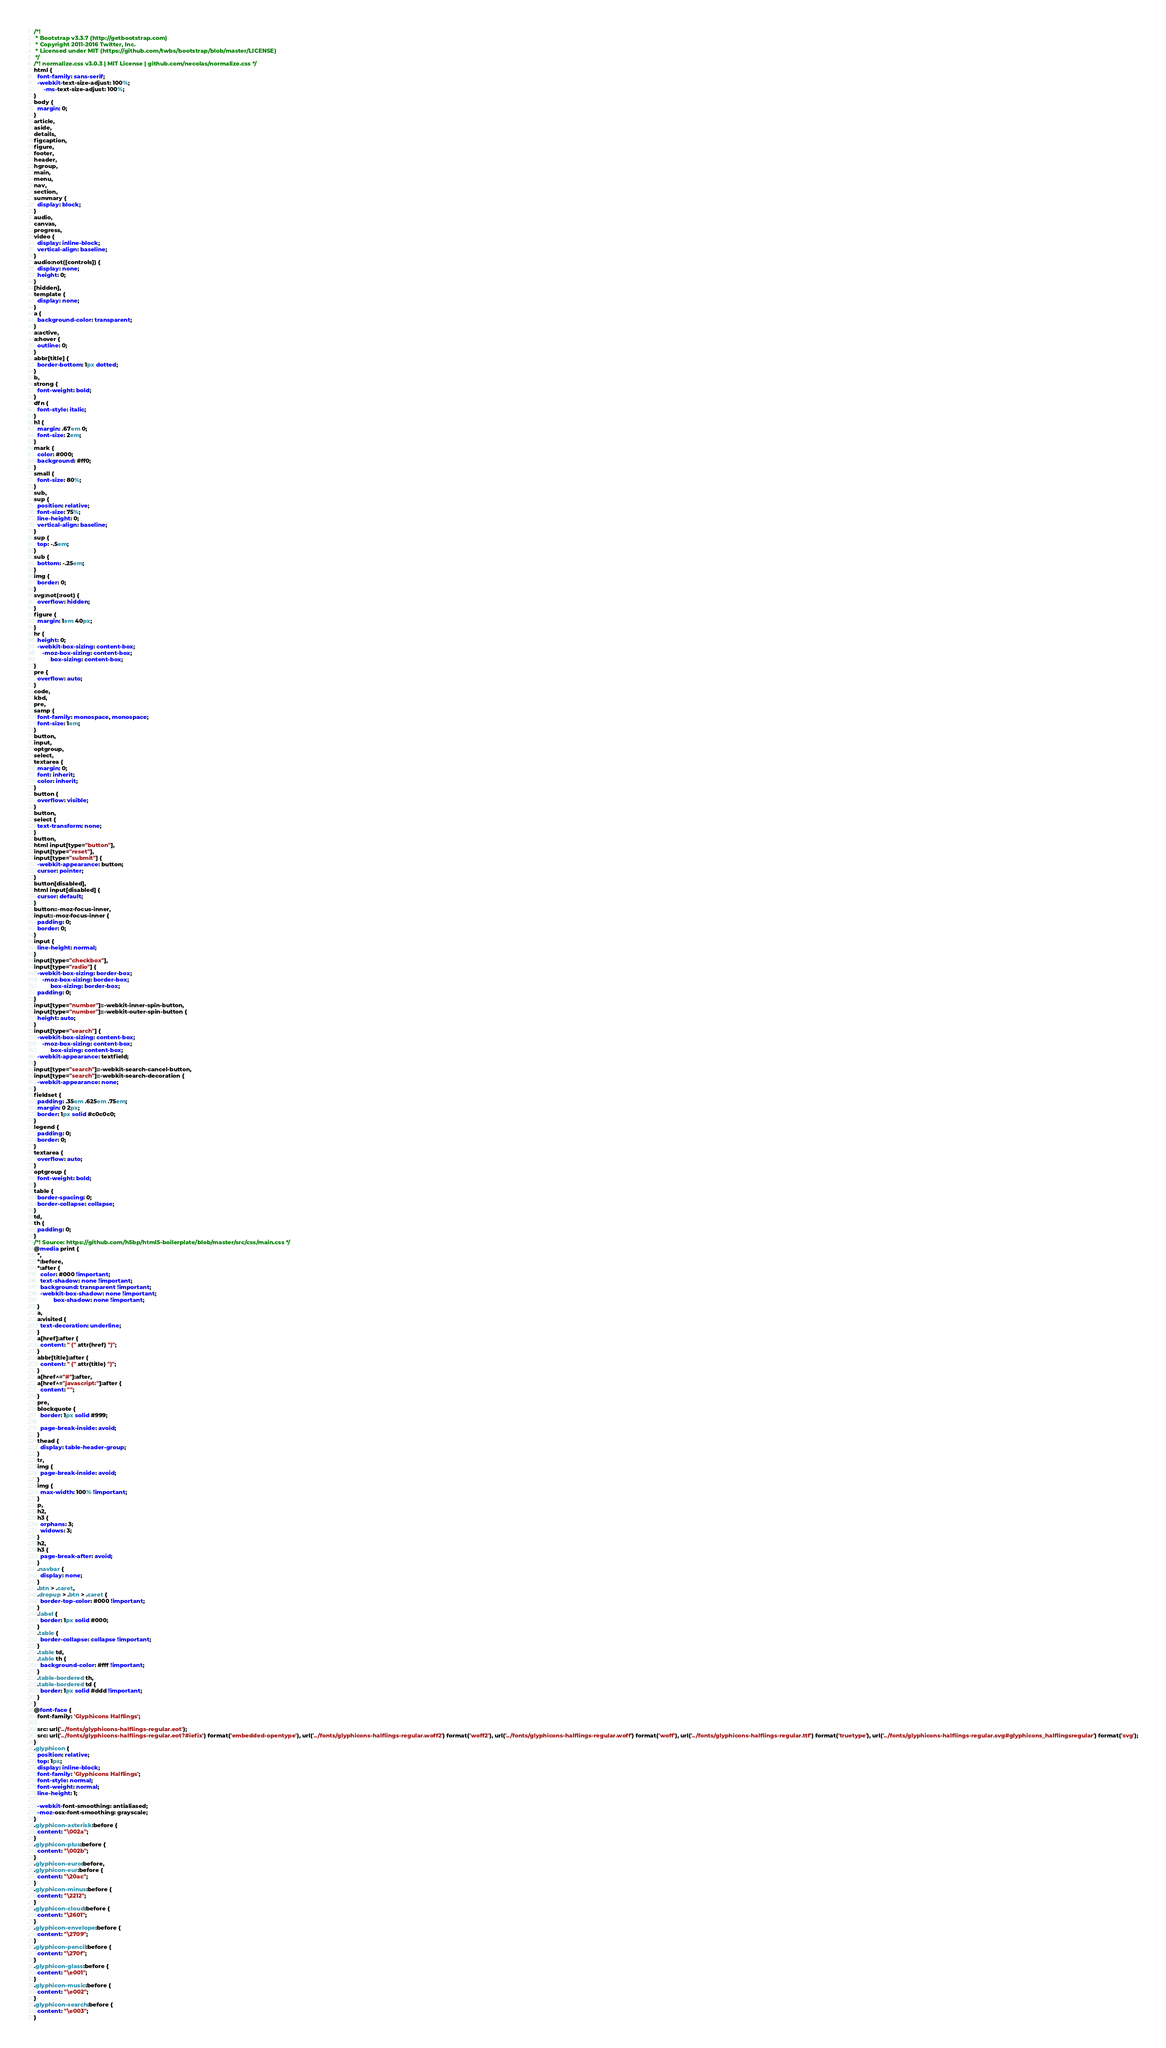Convert code to text. <code><loc_0><loc_0><loc_500><loc_500><_CSS_>/*!
 * Bootstrap v3.3.7 (http://getbootstrap.com)
 * Copyright 2011-2016 Twitter, Inc.
 * Licensed under MIT (https://github.com/twbs/bootstrap/blob/master/LICENSE)
 */
/*! normalize.css v3.0.3 | MIT License | github.com/necolas/normalize.css */
html {
  font-family: sans-serif;
  -webkit-text-size-adjust: 100%;
      -ms-text-size-adjust: 100%;
}
body {
  margin: 0;
}
article,
aside,
details,
figcaption,
figure,
footer,
header,
hgroup,
main,
menu,
nav,
section,
summary {
  display: block;
}
audio,
canvas,
progress,
video {
  display: inline-block;
  vertical-align: baseline;
}
audio:not([controls]) {
  display: none;
  height: 0;
}
[hidden],
template {
  display: none;
}
a {
  background-color: transparent;
}
a:active,
a:hover {
  outline: 0;
}
abbr[title] {
  border-bottom: 1px dotted;
}
b,
strong {
  font-weight: bold;
}
dfn {
  font-style: italic;
}
h1 {
  margin: .67em 0;
  font-size: 2em;
}
mark {
  color: #000;
  background: #ff0;
}
small {
  font-size: 80%;
}
sub,
sup {
  position: relative;
  font-size: 75%;
  line-height: 0;
  vertical-align: baseline;
}
sup {
  top: -.5em;
}
sub {
  bottom: -.25em;
}
img {
  border: 0;
}
svg:not(:root) {
  overflow: hidden;
}
figure {
  margin: 1em 40px;
}
hr {
  height: 0;
  -webkit-box-sizing: content-box;
     -moz-box-sizing: content-box;
          box-sizing: content-box;
}
pre {
  overflow: auto;
}
code,
kbd,
pre,
samp {
  font-family: monospace, monospace;
  font-size: 1em;
}
button,
input,
optgroup,
select,
textarea {
  margin: 0;
  font: inherit;
  color: inherit;
}
button {
  overflow: visible;
}
button,
select {
  text-transform: none;
}
button,
html input[type="button"],
input[type="reset"],
input[type="submit"] {
  -webkit-appearance: button;
  cursor: pointer;
}
button[disabled],
html input[disabled] {
  cursor: default;
}
button::-moz-focus-inner,
input::-moz-focus-inner {
  padding: 0;
  border: 0;
}
input {
  line-height: normal;
}
input[type="checkbox"],
input[type="radio"] {
  -webkit-box-sizing: border-box;
     -moz-box-sizing: border-box;
          box-sizing: border-box;
  padding: 0;
}
input[type="number"]::-webkit-inner-spin-button,
input[type="number"]::-webkit-outer-spin-button {
  height: auto;
}
input[type="search"] {
  -webkit-box-sizing: content-box;
     -moz-box-sizing: content-box;
          box-sizing: content-box;
  -webkit-appearance: textfield;
}
input[type="search"]::-webkit-search-cancel-button,
input[type="search"]::-webkit-search-decoration {
  -webkit-appearance: none;
}
fieldset {
  padding: .35em .625em .75em;
  margin: 0 2px;
  border: 1px solid #c0c0c0;
}
legend {
  padding: 0;
  border: 0;
}
textarea {
  overflow: auto;
}
optgroup {
  font-weight: bold;
}
table {
  border-spacing: 0;
  border-collapse: collapse;
}
td,
th {
  padding: 0;
}
/*! Source: https://github.com/h5bp/html5-boilerplate/blob/master/src/css/main.css */
@media print {
  *,
  *:before,
  *:after {
    color: #000 !important;
    text-shadow: none !important;
    background: transparent !important;
    -webkit-box-shadow: none !important;
            box-shadow: none !important;
  }
  a,
  a:visited {
    text-decoration: underline;
  }
  a[href]:after {
    content: " (" attr(href) ")";
  }
  abbr[title]:after {
    content: " (" attr(title) ")";
  }
  a[href^="#"]:after,
  a[href^="javascript:"]:after {
    content: "";
  }
  pre,
  blockquote {
    border: 1px solid #999;

    page-break-inside: avoid;
  }
  thead {
    display: table-header-group;
  }
  tr,
  img {
    page-break-inside: avoid;
  }
  img {
    max-width: 100% !important;
  }
  p,
  h2,
  h3 {
    orphans: 3;
    widows: 3;
  }
  h2,
  h3 {
    page-break-after: avoid;
  }
  .navbar {
    display: none;
  }
  .btn > .caret,
  .dropup > .btn > .caret {
    border-top-color: #000 !important;
  }
  .label {
    border: 1px solid #000;
  }
  .table {
    border-collapse: collapse !important;
  }
  .table td,
  .table th {
    background-color: #fff !important;
  }
  .table-bordered th,
  .table-bordered td {
    border: 1px solid #ddd !important;
  }
}
@font-face {
  font-family: 'Glyphicons Halflings';

  src: url('../fonts/glyphicons-halflings-regular.eot');
  src: url('../fonts/glyphicons-halflings-regular.eot?#iefix') format('embedded-opentype'), url('../fonts/glyphicons-halflings-regular.woff2') format('woff2'), url('../fonts/glyphicons-halflings-regular.woff') format('woff'), url('../fonts/glyphicons-halflings-regular.ttf') format('truetype'), url('../fonts/glyphicons-halflings-regular.svg#glyphicons_halflingsregular') format('svg');
}
.glyphicon {
  position: relative;
  top: 1px;
  display: inline-block;
  font-family: 'Glyphicons Halflings';
  font-style: normal;
  font-weight: normal;
  line-height: 1;

  -webkit-font-smoothing: antialiased;
  -moz-osx-font-smoothing: grayscale;
}
.glyphicon-asterisk:before {
  content: "\002a";
}
.glyphicon-plus:before {
  content: "\002b";
}
.glyphicon-euro:before,
.glyphicon-eur:before {
  content: "\20ac";
}
.glyphicon-minus:before {
  content: "\2212";
}
.glyphicon-cloud:before {
  content: "\2601";
}
.glyphicon-envelope:before {
  content: "\2709";
}
.glyphicon-pencil:before {
  content: "\270f";
}
.glyphicon-glass:before {
  content: "\e001";
}
.glyphicon-music:before {
  content: "\e002";
}
.glyphicon-search:before {
  content: "\e003";
}</code> 